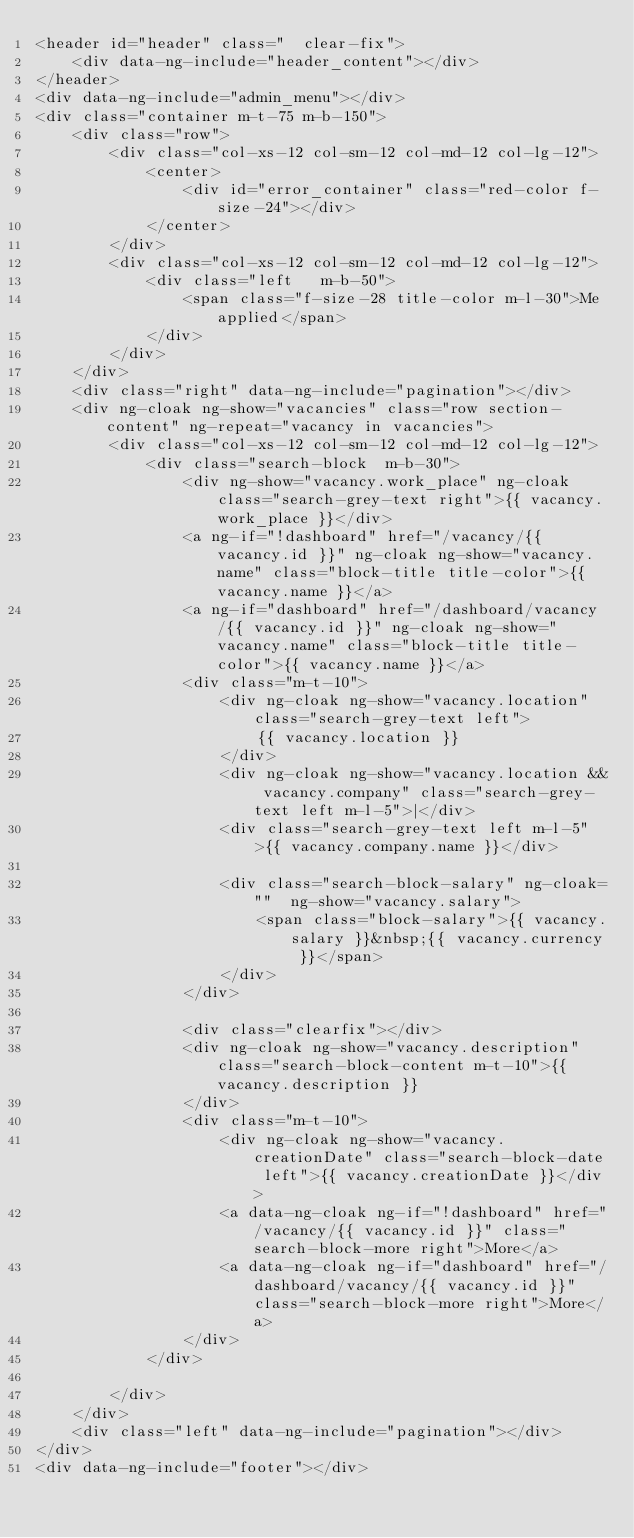Convert code to text. <code><loc_0><loc_0><loc_500><loc_500><_HTML_><header id="header" class="  clear-fix">
    <div data-ng-include="header_content"></div>
</header>
<div data-ng-include="admin_menu"></div>
<div class="container m-t-75 m-b-150">
    <div class="row">
        <div class="col-xs-12 col-sm-12 col-md-12 col-lg-12">
            <center>
                <div id="error_container" class="red-color f-size-24"></div>
            </center>
        </div>
        <div class="col-xs-12 col-sm-12 col-md-12 col-lg-12">
            <div class="left   m-b-50">
                <span class="f-size-28 title-color m-l-30">Me applied</span>
            </div>
        </div>
    </div>
    <div class="right" data-ng-include="pagination"></div>
    <div ng-cloak ng-show="vacancies" class="row section-content" ng-repeat="vacancy in vacancies">
        <div class="col-xs-12 col-sm-12 col-md-12 col-lg-12">
            <div class="search-block  m-b-30">
                <div ng-show="vacancy.work_place" ng-cloak class="search-grey-text right">{{ vacancy.work_place }}</div>
                <a ng-if="!dashboard" href="/vacancy/{{ vacancy.id }}" ng-cloak ng-show="vacancy.name" class="block-title title-color">{{ vacancy.name }}</a>
                <a ng-if="dashboard" href="/dashboard/vacancy/{{ vacancy.id }}" ng-cloak ng-show="vacancy.name" class="block-title title-color">{{ vacancy.name }}</a>
                <div class="m-t-10">
                    <div ng-cloak ng-show="vacancy.location" class="search-grey-text left">
                        {{ vacancy.location }}
                    </div>
                    <div ng-cloak ng-show="vacancy.location && vacancy.company" class="search-grey-text left m-l-5">|</div>
                    <div class="search-grey-text left m-l-5">{{ vacancy.company.name }}</div>

                    <div class="search-block-salary" ng-cloak=""  ng-show="vacancy.salary">
                        <span class="block-salary">{{ vacancy.salary }}&nbsp;{{ vacancy.currency }}</span>
                    </div>
                </div>

                <div class="clearfix"></div>
                <div ng-cloak ng-show="vacancy.description" class="search-block-content m-t-10">{{ vacancy.description }}
                </div>
                <div class="m-t-10">
                    <div ng-cloak ng-show="vacancy.creationDate" class="search-block-date left">{{ vacancy.creationDate }}</div>
                    <a data-ng-cloak ng-if="!dashboard" href="/vacancy/{{ vacancy.id }}" class="search-block-more right">More</a>
                    <a data-ng-cloak ng-if="dashboard" href="/dashboard/vacancy/{{ vacancy.id }}" class="search-block-more right">More</a>
                </div>
            </div>

        </div>
    </div>
    <div class="left" data-ng-include="pagination"></div>
</div>
<div data-ng-include="footer"></div></code> 